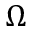Convert formula to latex. <formula><loc_0><loc_0><loc_500><loc_500>\Omega</formula> 